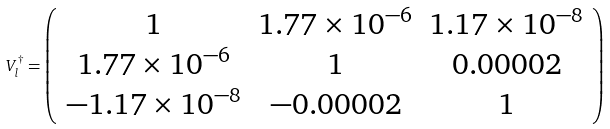<formula> <loc_0><loc_0><loc_500><loc_500>V _ { l } ^ { \dagger } = \left ( \begin{array} { c c c } 1 & 1 . 7 7 \times 1 0 ^ { - 6 } & 1 . 1 7 \times 1 0 ^ { - 8 } \\ 1 . 7 7 \times 1 0 ^ { - 6 } & 1 & 0 . 0 0 0 0 2 \\ - 1 . 1 7 \times 1 0 ^ { - 8 } & - 0 . 0 0 0 0 2 & 1 \end{array} \right )</formula> 